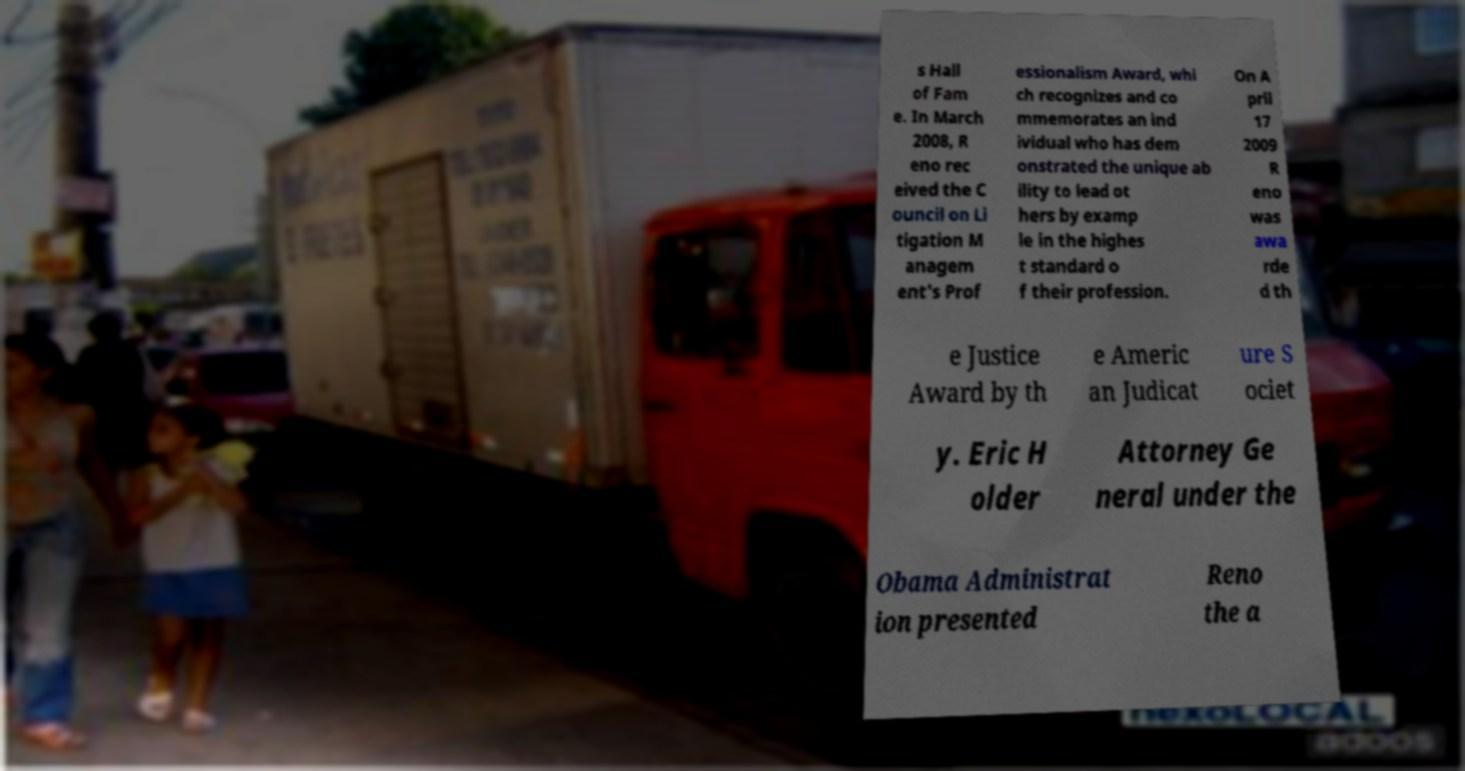Can you describe the scene behind the text in the image? Certainly! The image shows a street scene with several people walking on the sidewalk. There's a child in a bright yellow top, and behind the text overlay, you can spot a red vehicle, which seems to be a delivery truck. The scene appears to be set in a busy urban area with various vehicles and structures, suggesting everyday life in a city. 